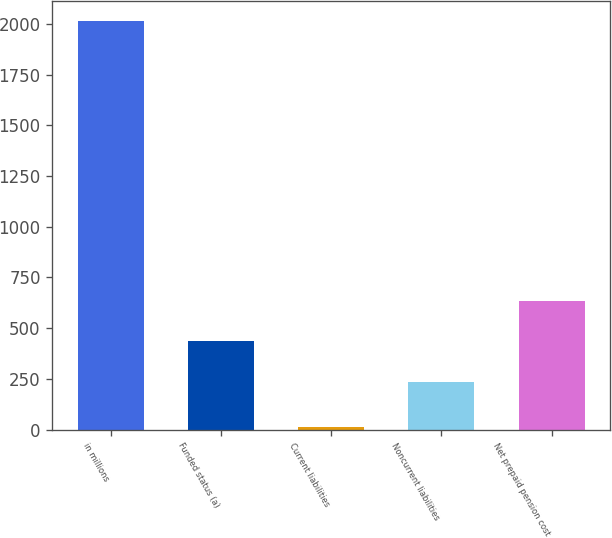Convert chart. <chart><loc_0><loc_0><loc_500><loc_500><bar_chart><fcel>in millions<fcel>Funded status (a)<fcel>Current liabilities<fcel>Noncurrent liabilities<fcel>Net prepaid pension cost<nl><fcel>2014<fcel>435<fcel>14<fcel>235<fcel>635<nl></chart> 